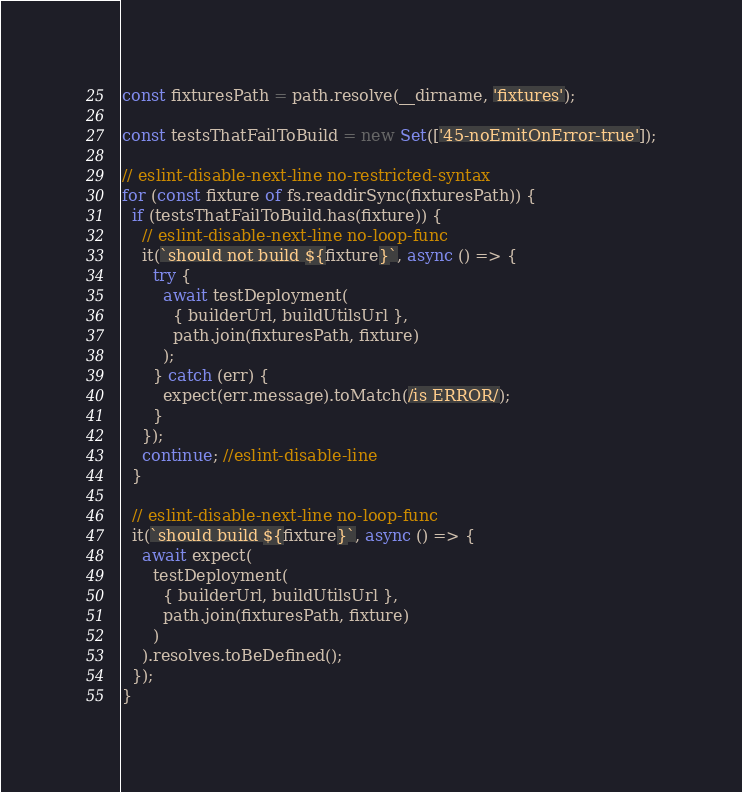<code> <loc_0><loc_0><loc_500><loc_500><_JavaScript_>const fixturesPath = path.resolve(__dirname, 'fixtures');

const testsThatFailToBuild = new Set(['45-noEmitOnError-true']);

// eslint-disable-next-line no-restricted-syntax
for (const fixture of fs.readdirSync(fixturesPath)) {
  if (testsThatFailToBuild.has(fixture)) {
    // eslint-disable-next-line no-loop-func
    it(`should not build ${fixture}`, async () => {
      try {
        await testDeployment(
          { builderUrl, buildUtilsUrl },
          path.join(fixturesPath, fixture)
        );
      } catch (err) {
        expect(err.message).toMatch(/is ERROR/);
      }
    });
    continue; //eslint-disable-line
  }

  // eslint-disable-next-line no-loop-func
  it(`should build ${fixture}`, async () => {
    await expect(
      testDeployment(
        { builderUrl, buildUtilsUrl },
        path.join(fixturesPath, fixture)
      )
    ).resolves.toBeDefined();
  });
}
</code> 